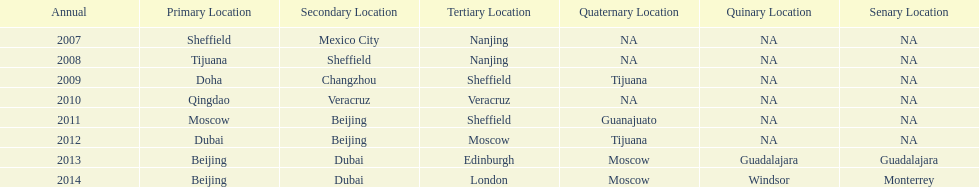Which two venue has no nations from 2007-2012 5th Venue, 6th Venue. 